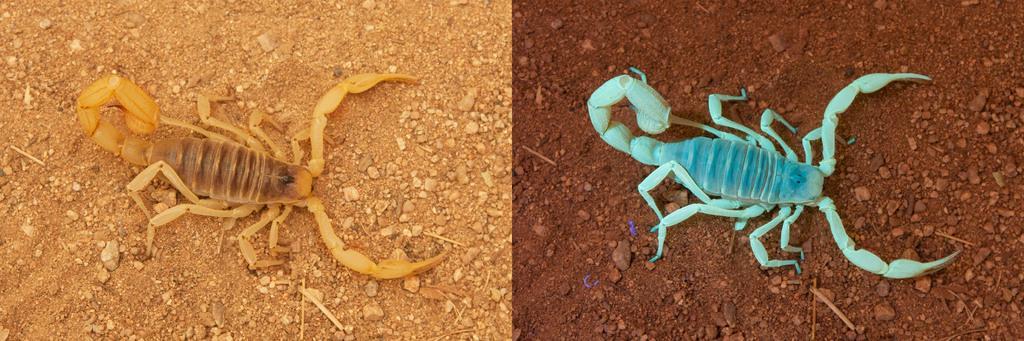Can you describe this image briefly? This is a collage image, in this image there are two scorpions on the land. 